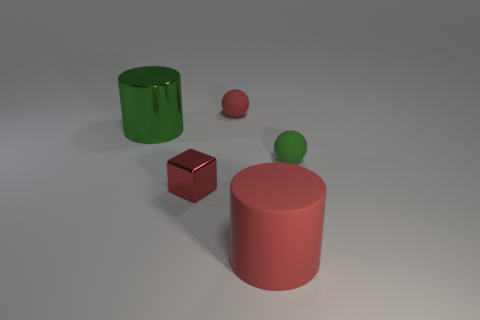Add 2 cyan cylinders. How many objects exist? 7 Subtract all balls. How many objects are left? 3 Add 3 matte cylinders. How many matte cylinders are left? 4 Add 3 tiny red metal balls. How many tiny red metal balls exist? 3 Subtract 0 yellow blocks. How many objects are left? 5 Subtract all small cubes. Subtract all red shiny blocks. How many objects are left? 3 